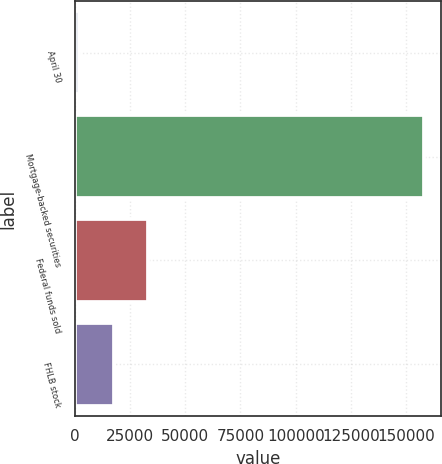Convert chart to OTSL. <chart><loc_0><loc_0><loc_500><loc_500><bar_chart><fcel>April 30<fcel>Mortgage-backed securities<fcel>Federal funds sold<fcel>FHLB stock<nl><fcel>2011<fcel>157970<fcel>33202.8<fcel>17606.9<nl></chart> 